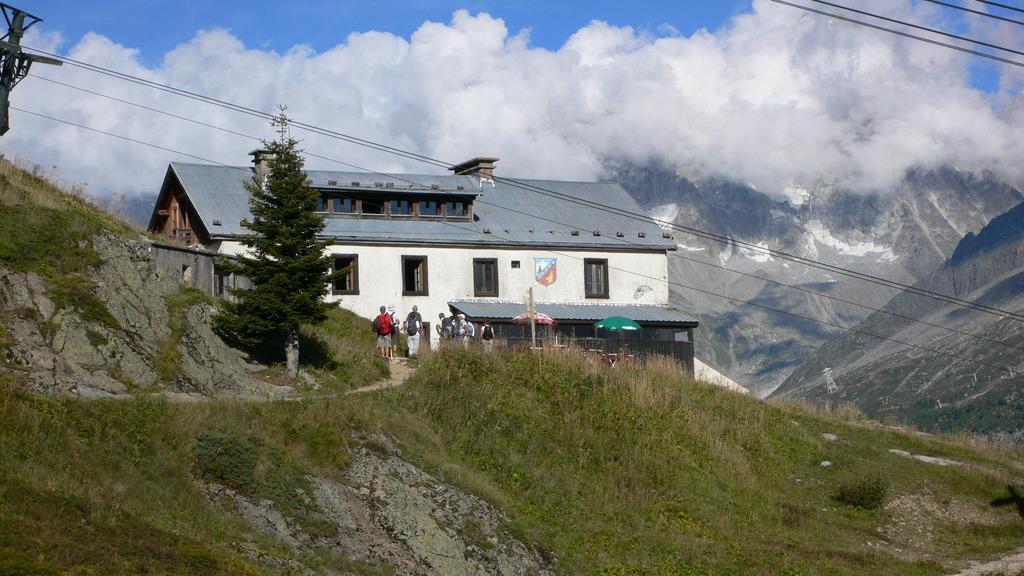Could you give a brief overview of what you see in this image? In this image there is a house in the middle. At the top there is the sky. In the background there are snow mountains. At the bottom there is grass. In the middle there are few people standing on the ground. 